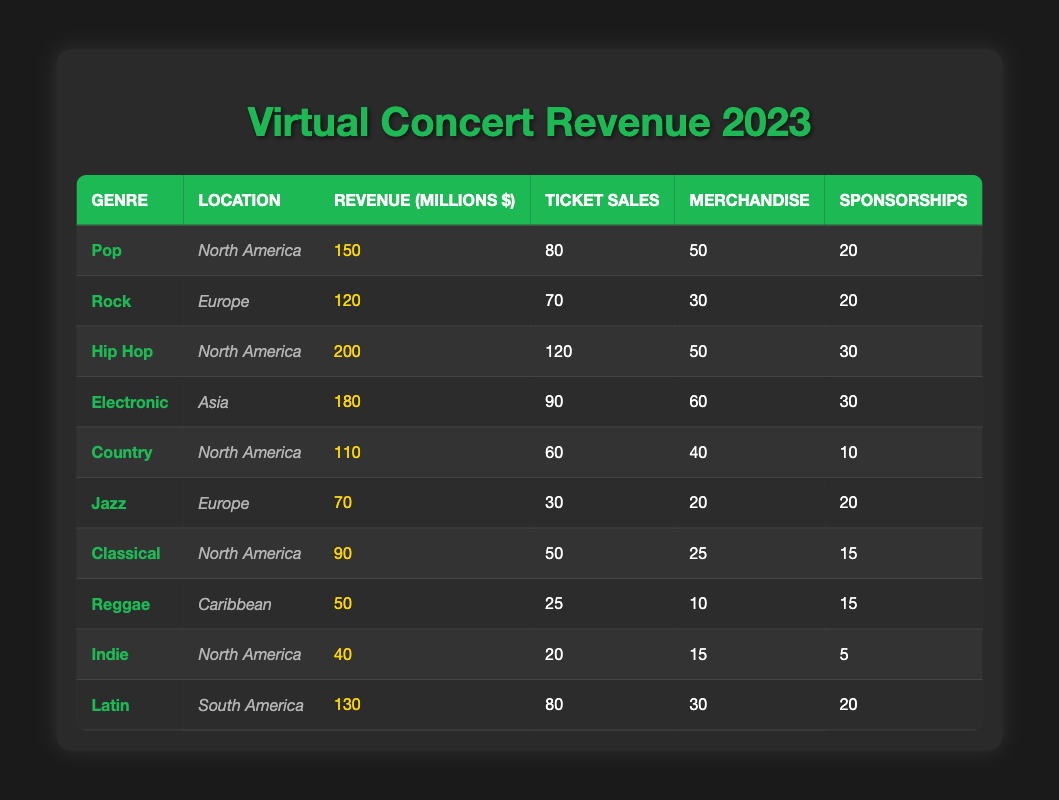What's the total revenue generated from Hip Hop concerts in North America? From the table, the revenue for Hip Hop concerts in North America is listed as 200 million.
Answer: 200 million Which genre generated the most revenue in Asia? The only genre listed under Asia is Electronic, with a revenue of 180 million.
Answer: Electronic What is the combined revenue from Pop and Latin concerts? Adding the revenues: Pop (150 million) + Latin (130 million) gives 280 million.
Answer: 280 million How much revenue did Country concerts generate compared to Jazz concerts in Europe? Country concerts generated 110 million, while Jazz concerts generated 70 million. The difference is 110 - 70 = 40 million.
Answer: 40 million more Did any genre generate more than 200 million in North America? No, the highest revenue in North America is 200 million from Hip Hop, which is equal but not greater than 200 million.
Answer: No What is the average revenue for North American concerts? The North American concerts have the following revenues: Pop (150), Hip Hop (200), Country (110), Classical (90), Indie (40). The total is 590 million and divided by 5 gives an average of 118 million.
Answer: 118 million Which genre had the highest ticket sales in North America? Hip Hop had the highest ticket sales at 120, followed by Pop at 80.
Answer: Hip Hop What is the total sponsorship revenue across all genres? Adding the sponsorships gives: 20 (Pop) + 20 (Rock) + 30 (Hip Hop) + 30 (Electronic) + 10 (Country) + 20 (Jazz) + 15 (Classical) + 15 (Reggae) + 5 (Indie) + 20 (Latin) = 250 million.
Answer: 250 million Which region had the lowest revenue from virtual concerts? The Caribbean, with Reggae concerts generating 50 million, is the lowest.
Answer: Caribbean Is the revenue from Latin concerts higher than the combined revenue from Jazz and Reggae? Latin concerts generated 130 million, while Jazz and Reggae together generated 70 + 50 = 120 million. Yes, 130 million is more than 120 million.
Answer: Yes 